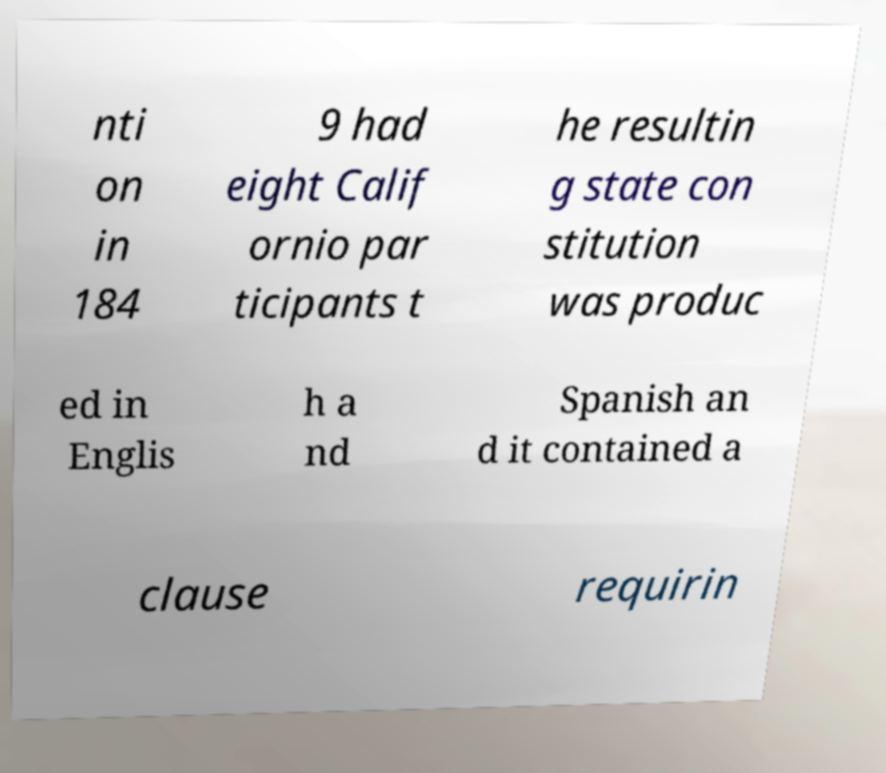Could you assist in decoding the text presented in this image and type it out clearly? nti on in 184 9 had eight Calif ornio par ticipants t he resultin g state con stitution was produc ed in Englis h a nd Spanish an d it contained a clause requirin 